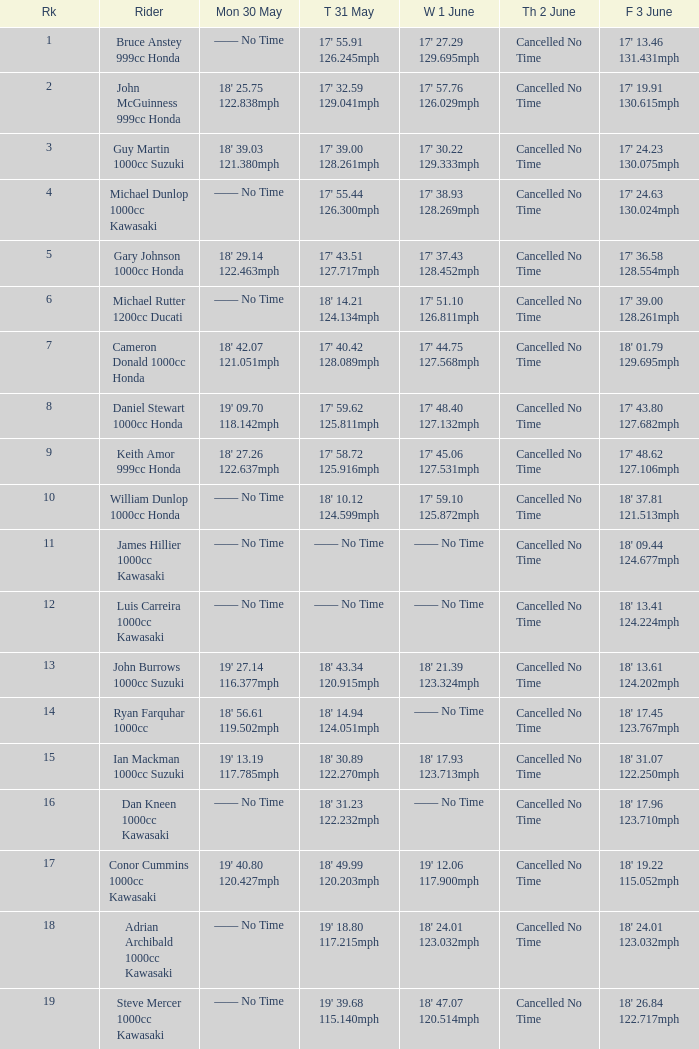What is the Fri 3 June time for the rider whose Tues 31 May time was 19' 18.80 117.215mph? 18' 24.01 123.032mph. 